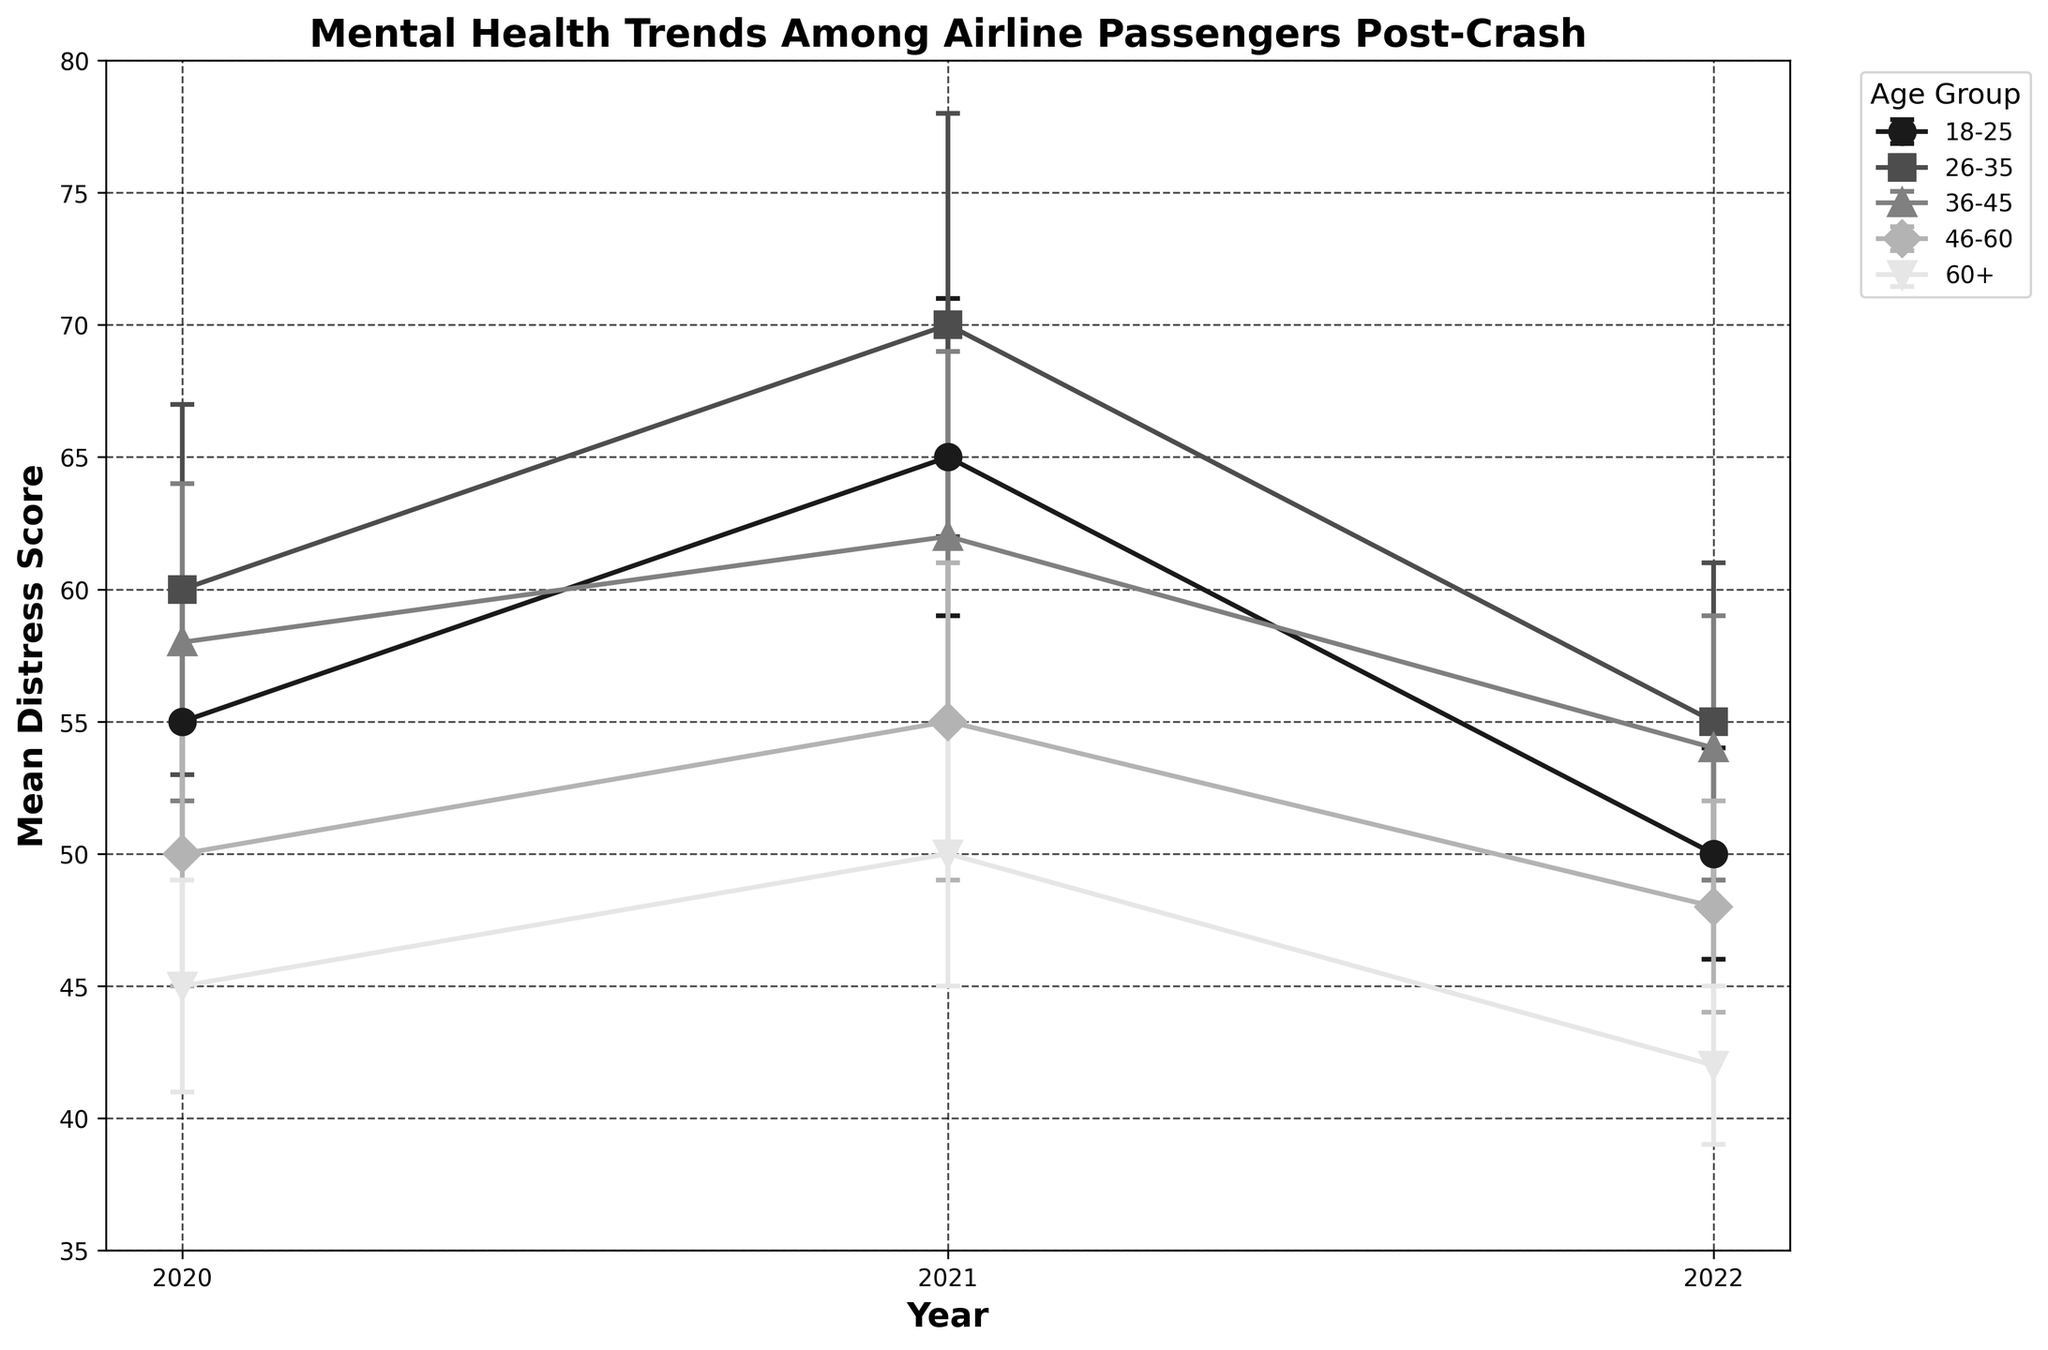What is the title of the figure? The title is at the top of the figure and usually summarizes the main insight of the visual representation.
Answer: Mental Health Trends Among Airline Passengers Post-Crash Which age group had the highest mean distress score in 2021? Look at the data points for all age groups in the year 2021 and identify the highest value.
Answer: 26-35 How did the mean distress score for the age group 60+ change from 2021 to 2022? Compare the mean distress scores for 60+ in 2021 and 2022 to find the difference.
Answer: Decreased What is the overall trend for the mean distress scores for the age group 18-25 from 2020 to 2022? Observe the mean distress scores for 18-25 across the years and describe the pattern.
Answer: Increased then decreased Which age group had the smallest error bars in 2022? Examine the length of error bars in 2022 for each age group and find the smallest one.
Answer: 60+ Is there a noticeable pattern in the distress scores across all age groups in 2021? Analyze the distress scores for all age groups in 2021 to see if there is any common trend.
Answer: Yes, scores peaked Which age group shows the most significant decrease in mean distress score from 2021 to 2022? Calculate the difference in mean distress scores from 2021 to 2022 for each age group and determine the largest drop.
Answer: 60+ How do the error bars for the 26-35 age group change from 2020 to 2022? Look at the 26-35 error bars over the years and describe their change.
Answer: Decreased slightly What is the mean distress score for the 46-60 age group in 2020? Find and report the mean distress score for the 46-60 age group for the year 2020.
Answer: 50 Which age group experienced the least change in mean distress score from 2020 to 2022? Compare the differences in mean distress scores for each age group from 2020 to 2022 and identify the smallest change.
Answer: 36-45 